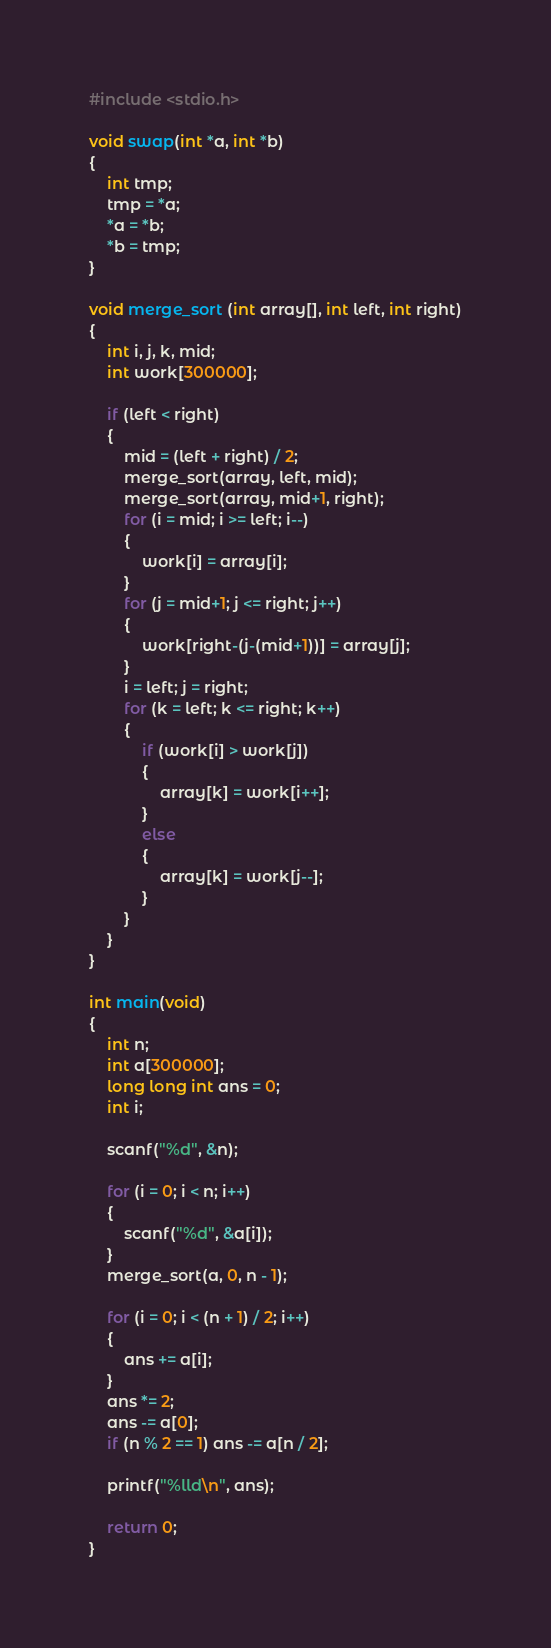Convert code to text. <code><loc_0><loc_0><loc_500><loc_500><_C_>#include <stdio.h>

void swap(int *a, int *b)
{
	int tmp;
	tmp = *a;
	*a = *b;
	*b = tmp;
}

void merge_sort (int array[], int left, int right)
{
	int i, j, k, mid;
	int work[300000];

	if (left < right)
	{
		mid = (left + right) / 2;
		merge_sort(array, left, mid);
		merge_sort(array, mid+1, right);
		for (i = mid; i >= left; i--)
		{
			work[i] = array[i];
		}
		for (j = mid+1; j <= right; j++)
		{
			work[right-(j-(mid+1))] = array[j];
		}
		i = left; j = right;
		for (k = left; k <= right; k++)
		{
			if (work[i] > work[j])
			{
				array[k] = work[i++];
			}
			else
			{
				array[k] = work[j--];
			}
		}
	}
}

int main(void)
{
	int n;
	int a[300000];
	long long int ans = 0;
	int i;

	scanf("%d", &n);

	for (i = 0; i < n; i++)
	{
		scanf("%d", &a[i]);
	}
	merge_sort(a, 0, n - 1);

	for (i = 0; i < (n + 1) / 2; i++)
	{
		ans += a[i];
	}
	ans *= 2;
	ans -= a[0];
	if (n % 2 == 1) ans -= a[n / 2];

	printf("%lld\n", ans);

	return 0;
}
</code> 